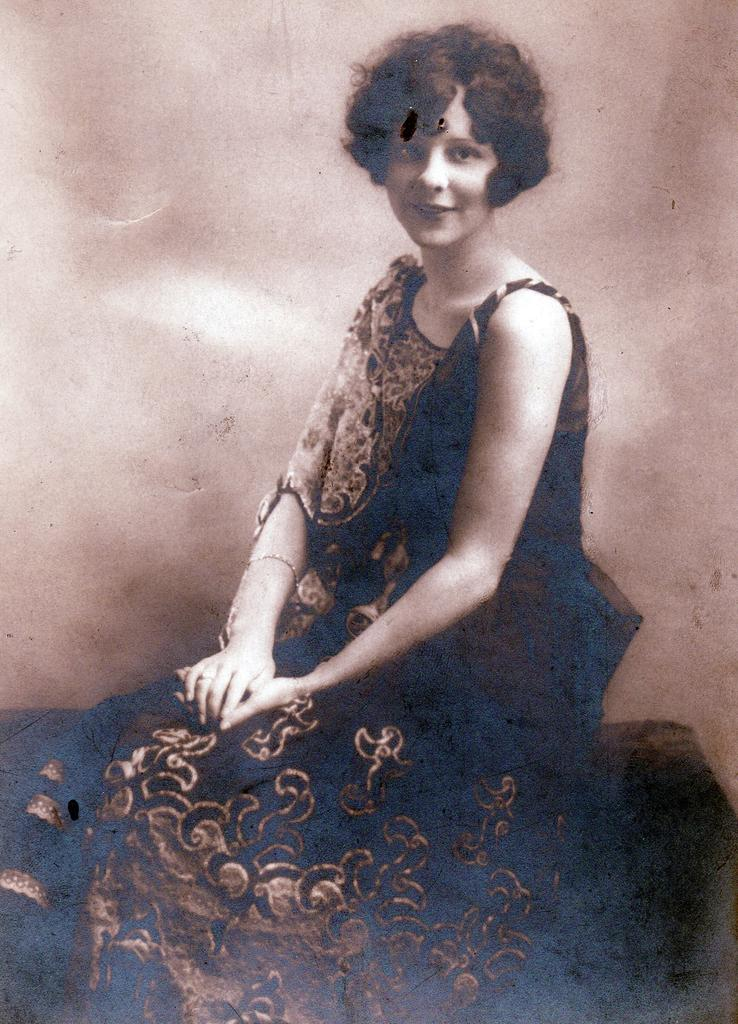What is the main subject of the image? There is a photo in the image. Who or what is depicted in the photo? The photo contains a woman. What is the woman doing in the photo? The woman is sitting. What is the woman's facial expression in the photo? The woman is smiling. What type of scale can be seen in the image? There is no scale present in the image; it features a photo of a woman sitting and smiling. Can you hear any noise coming from the image? The image is a still photo, so there is no sound or noise associated with it. 